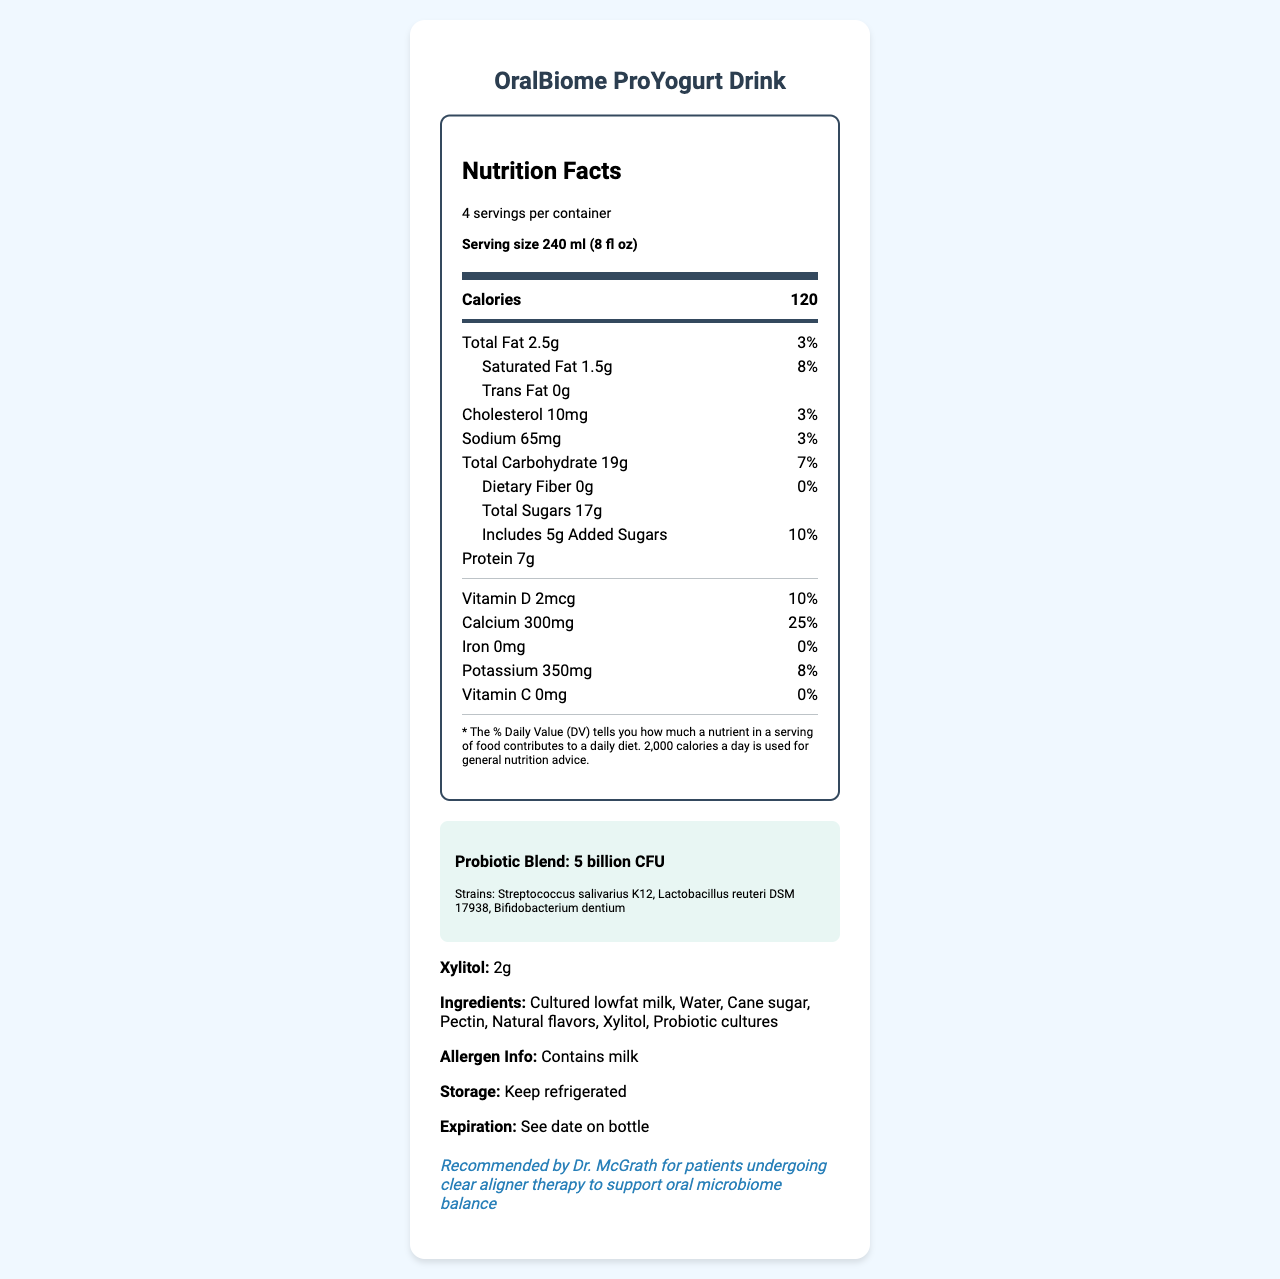what is the serving size of the OralBiome ProYogurt Drink? The serving size is clearly indicated in the document as "240 ml (8 fl oz)".
Answer: 240 ml (8 fl oz) how many servings are in each container of OralBiome ProYogurt Drink? The document states that there are 4 servings per container.
Answer: 4 servings per container how many calories are in one serving of OralBiome ProYogurt Drink? The document mentions that one serving contains 120 calories.
Answer: 120 calories name three probiotic strains included in the OralBiome ProYogurt Drink. The document lists these strains under the probiotic blend section.
Answer: Streptococcus salivarius K12, Lactobacillus reuteri DSM 17938, Bifidobacterium dentium what is the percentage daily value of calcium in the OralBiome ProYogurt Drink? The percentage daily value for calcium is given as 25%.
Answer: 25% which of the following is an ingredient in the OralBiome ProYogurt Drink?
A. High fructose corn syrup
B. Xylitol
C. Aspartame
D. Artificial flavors Out of the options provided, "Xylitol" is listed as an ingredient in the document.
Answer: B how much xylitol is contained in one serving of the OralBiome ProYogurt Drink?
A. 1g
B. 2g
C. 3g
D. 4g The document specifies that there are 2g of xylitol per serving.
Answer: B Is the OralBiome ProYogurt Drink recommended by Dr. McGrath for patients undergoing clear aligner therapy? The document features an orthodontic note stating that it is recommended by Dr. McGrath for such patients.
Answer: Yes How should the OralBiome ProYogurt Drink be stored? The storage information in the document advises keeping the product refrigerated.
Answer: Keep refrigerated summarize the main idea of the document. The document outlines the nutritional benefits and specific ingredients of the OralBiome ProYogurt Drink, highlighting its probiotic content and endorsement by Dr. McGrath for patients with clear aligners.
Answer: The document provides detailed nutrition facts and ingredient information for the OralBiome ProYogurt Drink, a probiotic yogurt aimed at improving oral microbiome health, including its dietary contributions, probiotic strains, serving size, and recommendations for orthodontic patients. what is the expiration date of the OralBiome ProYogurt Drink? The document instructs to "See date on bottle" for expiration information, so the actual date is not provided directly in the document.
Answer: Not enough information 